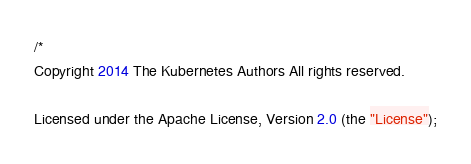<code> <loc_0><loc_0><loc_500><loc_500><_Go_>/*
Copyright 2014 The Kubernetes Authors All rights reserved.

Licensed under the Apache License, Version 2.0 (the "License");</code> 